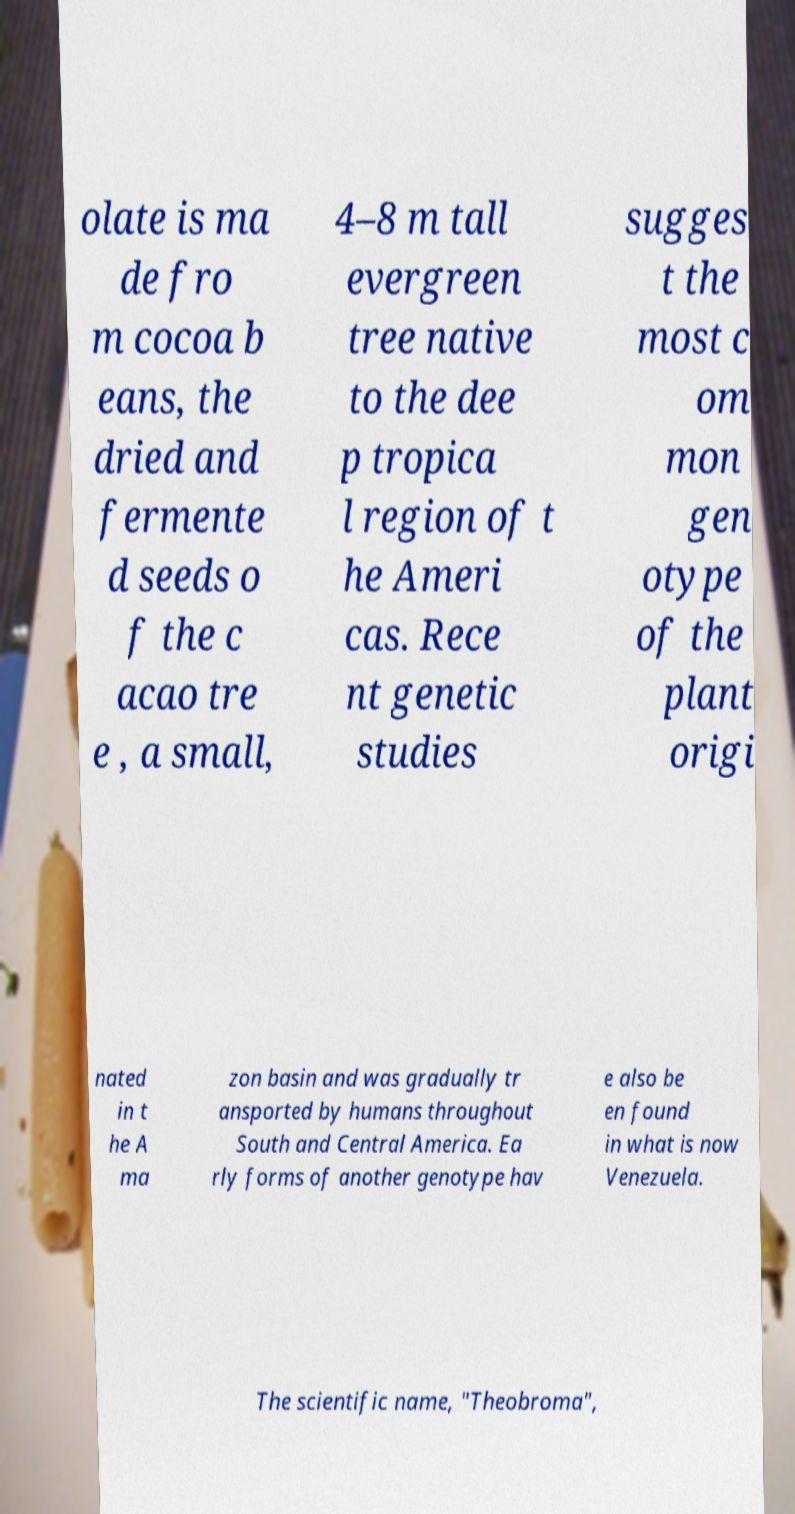Please identify and transcribe the text found in this image. olate is ma de fro m cocoa b eans, the dried and fermente d seeds o f the c acao tre e , a small, 4–8 m tall evergreen tree native to the dee p tropica l region of t he Ameri cas. Rece nt genetic studies sugges t the most c om mon gen otype of the plant origi nated in t he A ma zon basin and was gradually tr ansported by humans throughout South and Central America. Ea rly forms of another genotype hav e also be en found in what is now Venezuela. The scientific name, "Theobroma", 